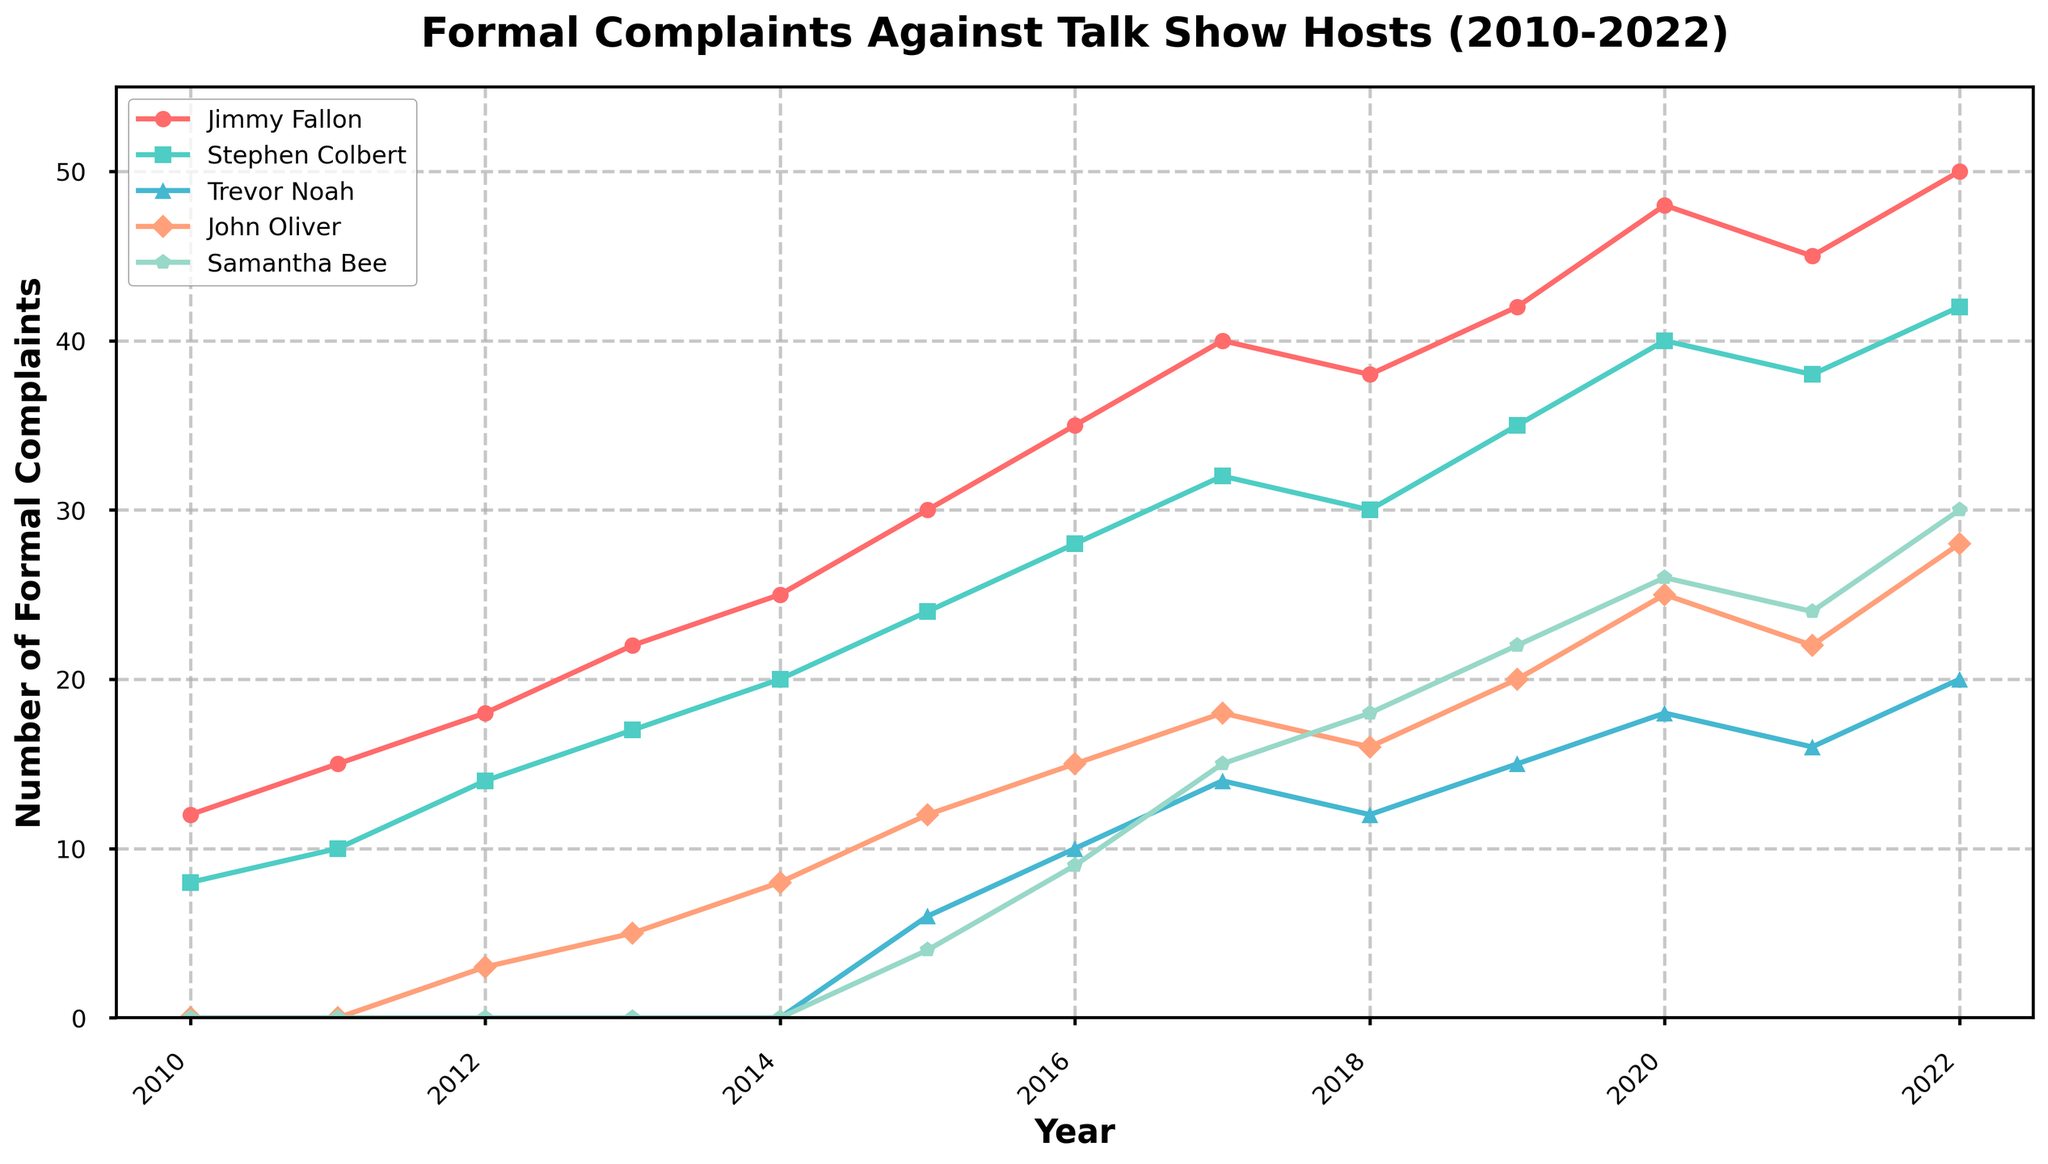How many more formal complaints were filed against Jimmy Fallon compared to Stephen Colbert in 2022? In 2022, Jimmy Fallon had 50 complaints, and Stephen Colbert had 42 complaints. Subtracting these values, 50 - 42 = 8
Answer: 8 Which year did Samantha Bee experience the highest number of complaints, and what is that number? Observing Samantha Bee's trend line, the highest number of complaints is in 2022, where it reaches 30
Answer: 2022, 30 In which year did John Oliver's formal complaints first exceed 10? Tracking John Oliver's line, the first year the number of complaints exceeds 10 is 2015
Answer: 2015 What is the sum of formal complaints for Trevor Noah and John Oliver in 2016? Trevor Noah had 10 complaints and John Oliver had 15 complaints in 2016. Summing these values, 10 + 15 = 25
Answer: 25 Compare the trend in formal complaints from 2019 to 2021 for Stephen Colbert and John Oliver. Who had a decrease? Stephen Colbert's complaints went from 35 in 2019 to 38 in 2021 (increase), while John Oliver's complaints went from 20 in 2019 to 22 in 2021 (increase). Neither had a decrease
Answer: Neither How does the slope of formal complaints for Jimmy Fallon from 2010 to 2020 appear compared to Samantha Bee's from 2015 to 2022? Jimmy Fallon’s trend line shows a consistent increase from 12 in 2010 to 48 in 2020, appearing steeper compared to Samantha Bee's slope from 4 in 2015 to 30 in 2022
Answer: Jimmy Fallon’s slope is steeper Which talk show host had the smallest increase in formal complaints from 2010 to 2022? Trevor Noah had no complaints until 2015. Totaling the increase between 2015 and 2022 results in an increase from 6 to 20, which is a 14-point increase — the smallest among all hosts considering the overall period from 2010 to 2022
Answer: Trevor Noah Which color indicates formal complaints for John Oliver, and what is the pattern of his trend line? The color for John Oliver is orange, and the trend shows a steady increase in complaints from 3 in 2012, leveling slightly or declining only in 2018 and 2021
Answer: Orange, steady increase What are the peak complaints and the year they occur for both Jimmy Fallon and Samantha Bee? Jimmy Fallon's peak complaints are 50 in 2022, and Samantha Bee's peak complaints are 30 in 2022
Answer: 2022, 50 for Jimmy Fallon; 2022, 30 for Samantha Bee 